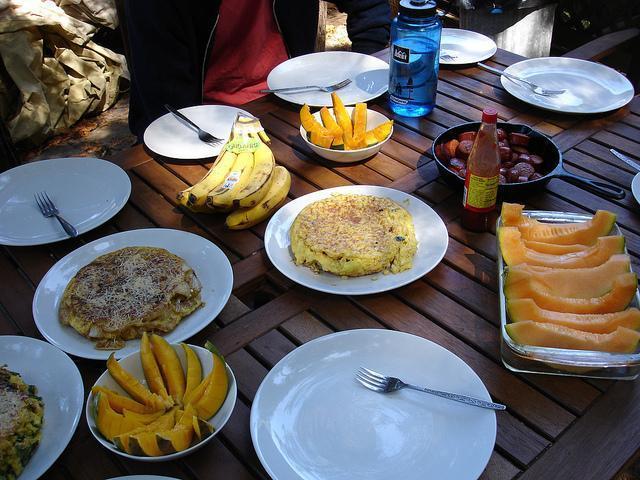How many plates are set at this table?
Give a very brief answer. 7. How many bottles can you see?
Give a very brief answer. 2. How many bowls can be seen?
Give a very brief answer. 2. How many levels does this bus have?
Give a very brief answer. 0. 